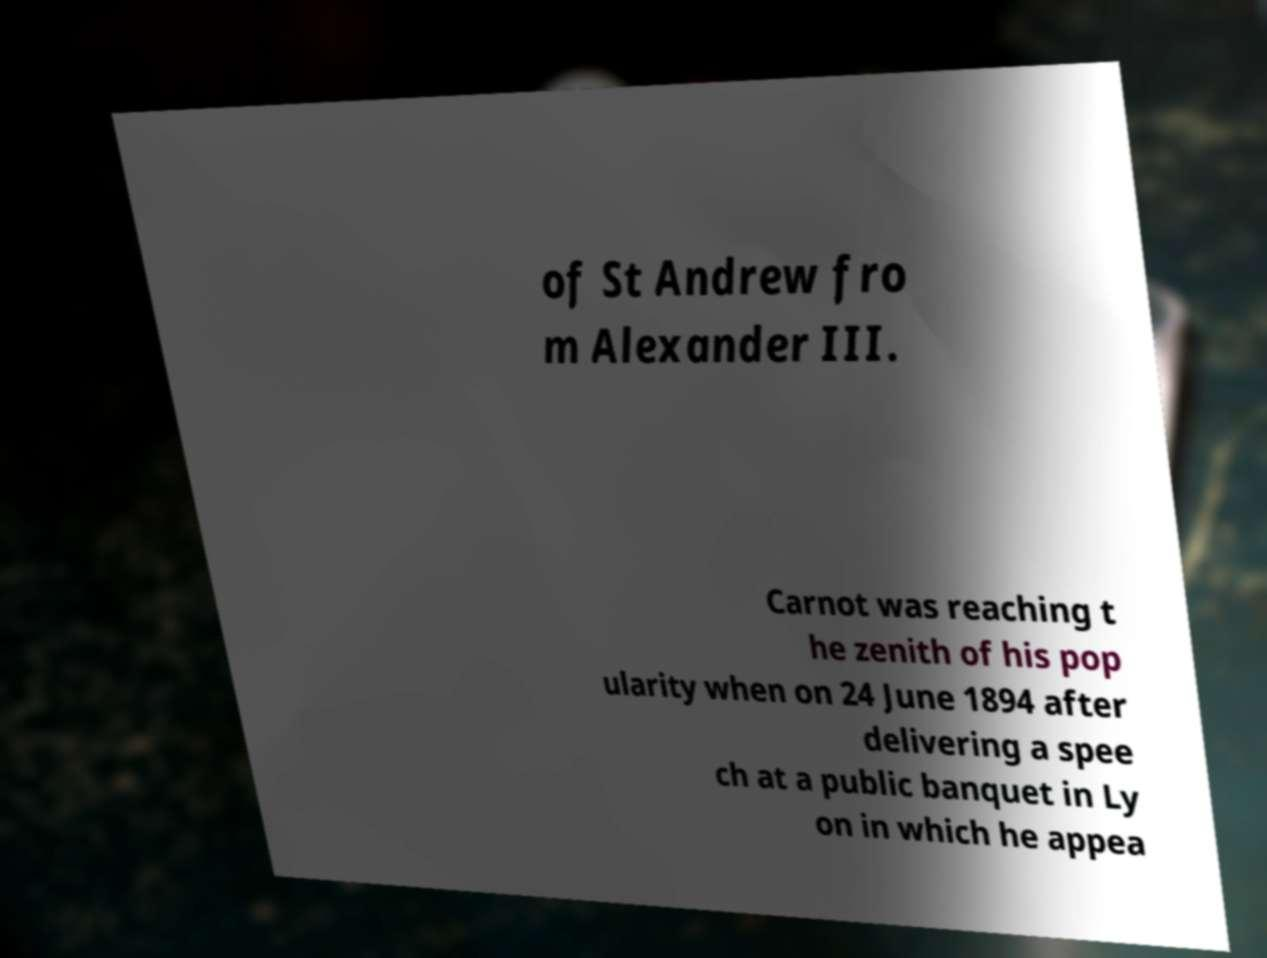Please identify and transcribe the text found in this image. of St Andrew fro m Alexander III. Carnot was reaching t he zenith of his pop ularity when on 24 June 1894 after delivering a spee ch at a public banquet in Ly on in which he appea 